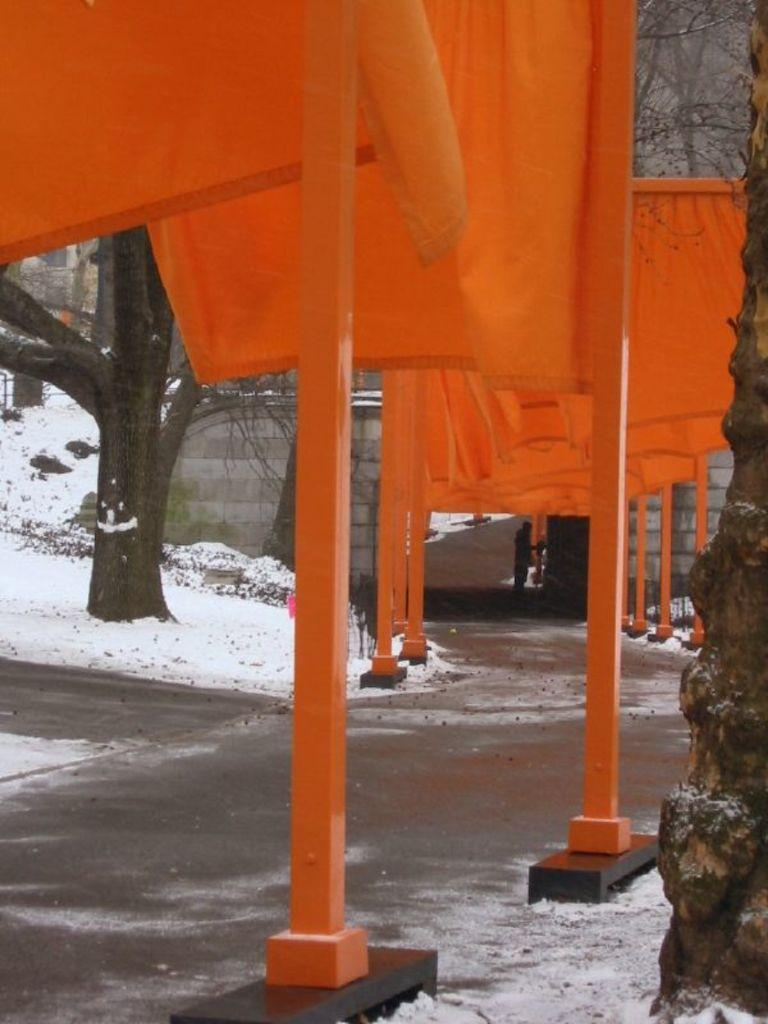What type of objects can be seen in the image? There are boards, buildings, and trees in the image. What is the ground covered with in the image? There is snow on the ground in the image. How many clocks can be seen hanging on the buildings in the image? There are no clocks visible on the buildings in the image. What type of material is used to construct the club in the image? There is no club present in the image. 